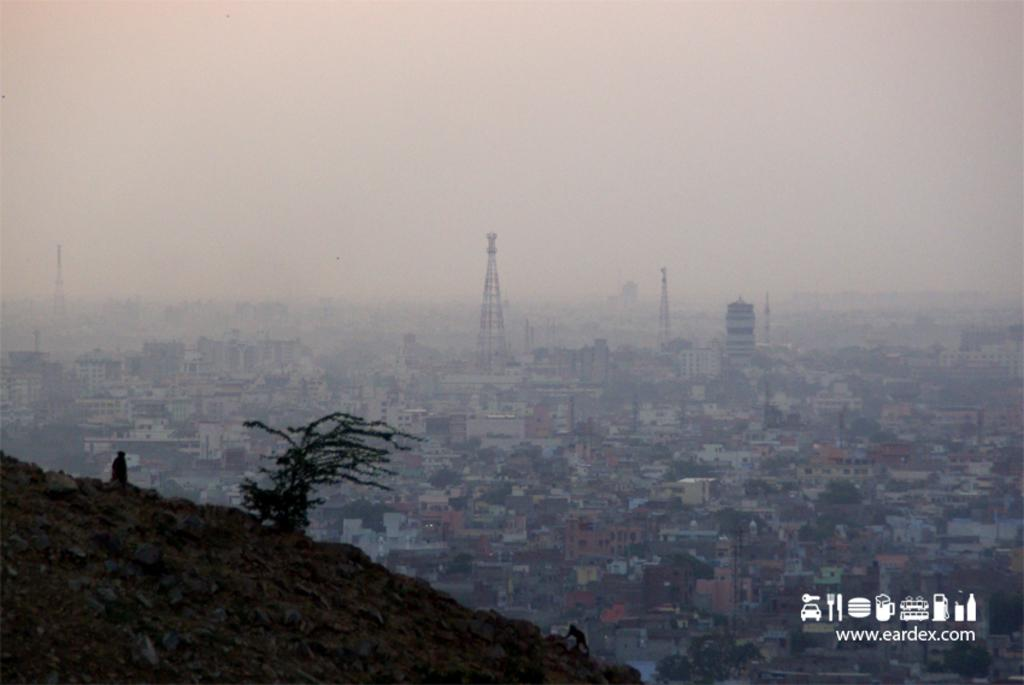What type of living organism can be seen in the image? There is a plant in the image. What other living organisms are present in the image? There are two animals in the image. What can be seen in the background of the image? There are buildings, trees, and the sky visible in the background of the image. Can you read the letter that the animals are fighting over in the image? There is no letter present in the image, nor are the animals fighting over anything. 